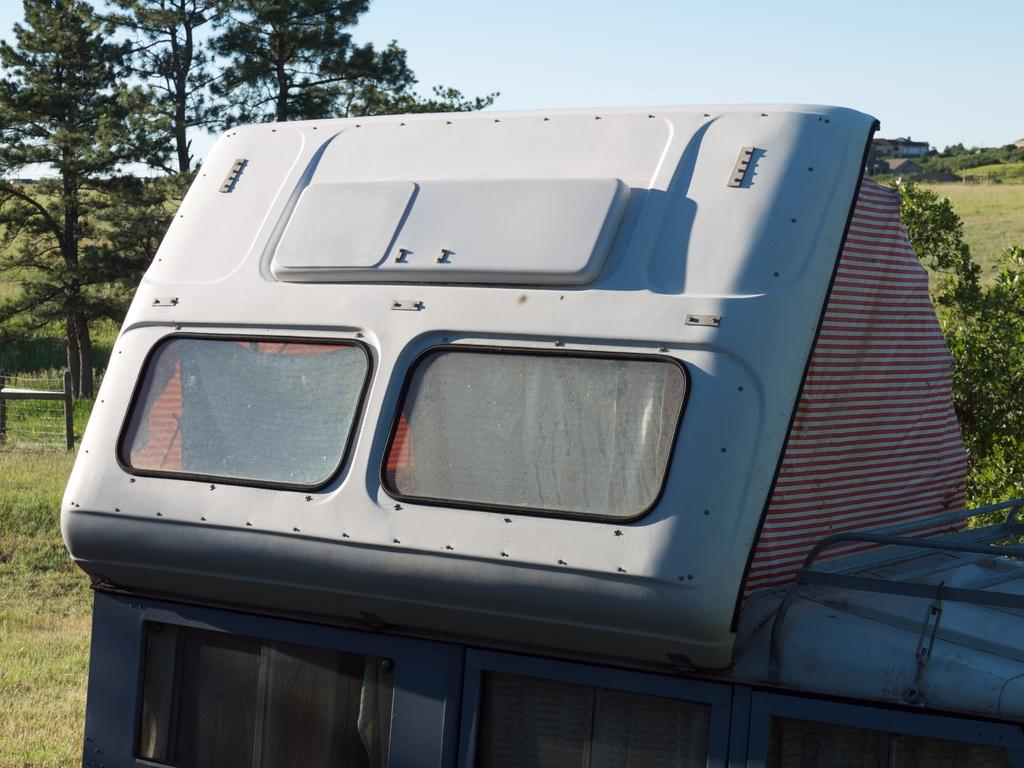What is the main subject in the center of the image? There is a truck in the center of the image. What can be seen in the background of the image? There are trees, grass, and the sky visible in the background of the image. Where is the lunchroom located in the image? There is no lunchroom present in the image. Can you see any stars in the image? There are no stars visible in the image; only the truck, trees, grass, and sky are present. 